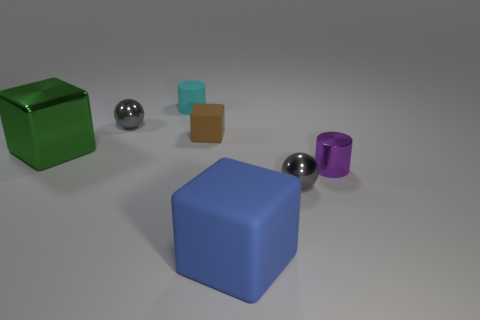Can you describe the lighting and shadows in the scene? The lighting in the image is diffused, with soft shadows cast under and to the right of each object, which suggests a light source located to the top left of the scene, outside of the frame. There is no harsh direct light, and the shadows have soft edges, indicating an environment that is likely indoors with ample ambient light. 